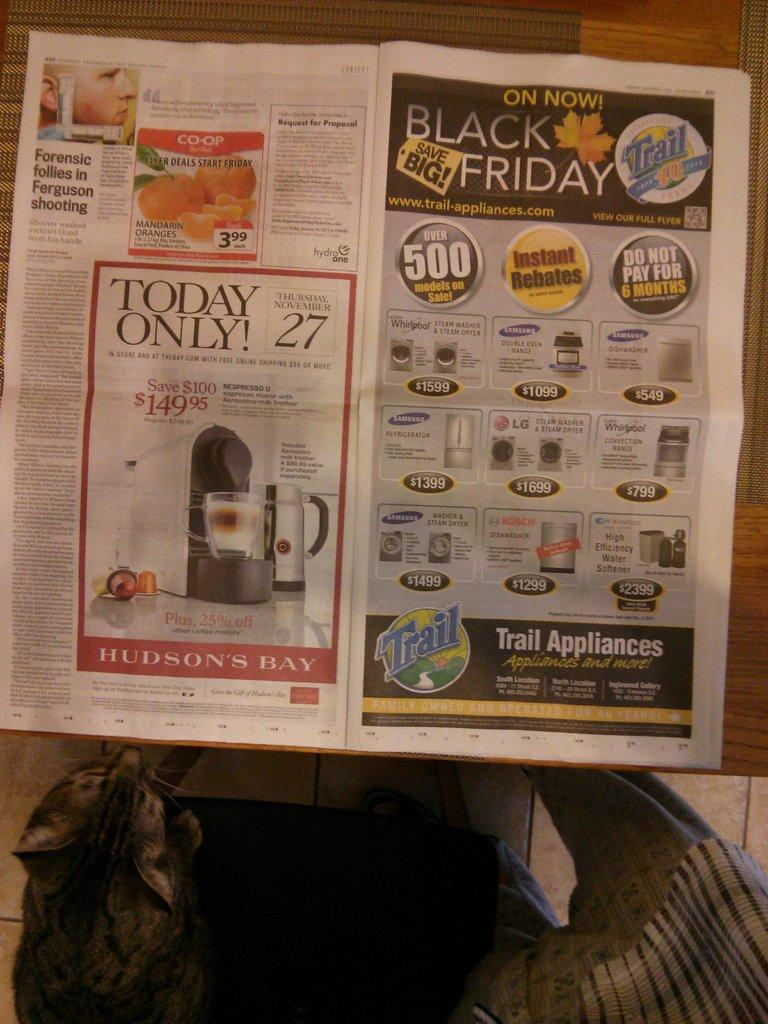What is present on the table in the image? There is a newspaper on a brown color table in the image. What is written on the newspaper? Something is written on the newspaper. What type of animal can be seen in the image? There is a cat in the image. Who else is present in the image besides the cat? There is a person in the image. What type of engine can be seen in the image? There is no engine present in the image. What activity is the person in the image participating in? The provided facts do not specify any activity the person is participating in. 